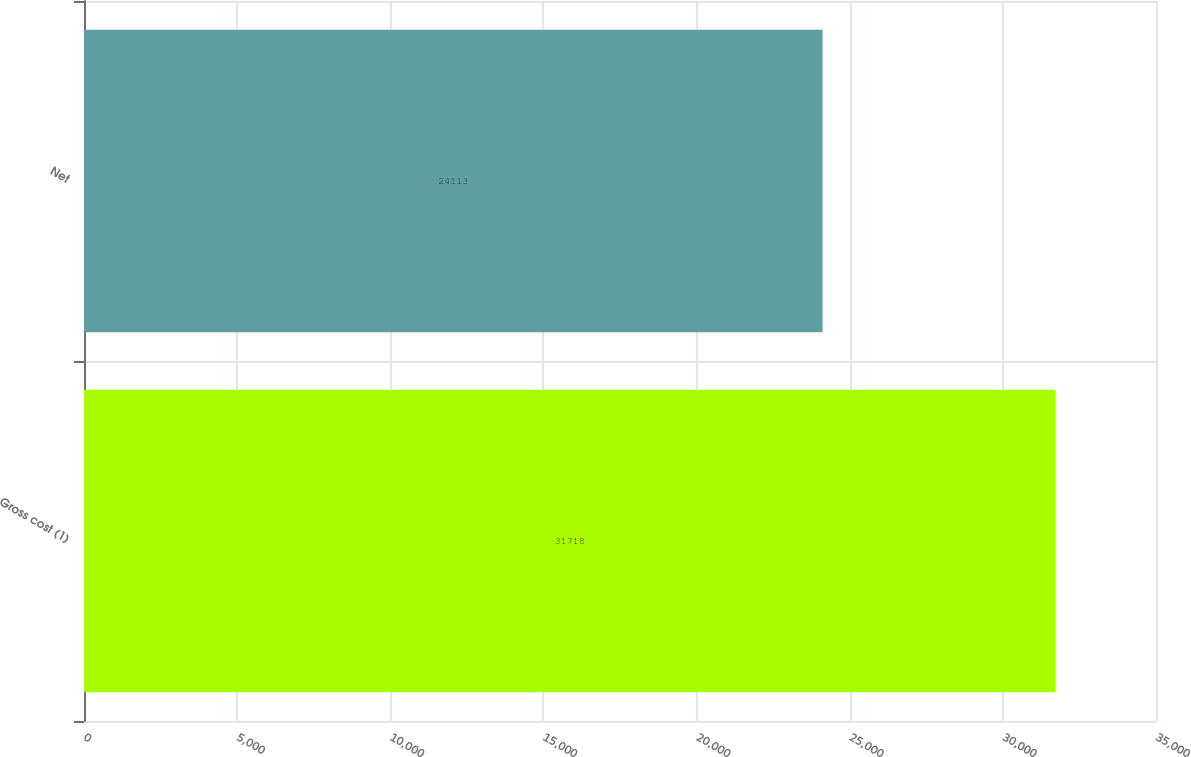<chart> <loc_0><loc_0><loc_500><loc_500><bar_chart><fcel>Gross cost (1)<fcel>Net<nl><fcel>31718<fcel>24113<nl></chart> 